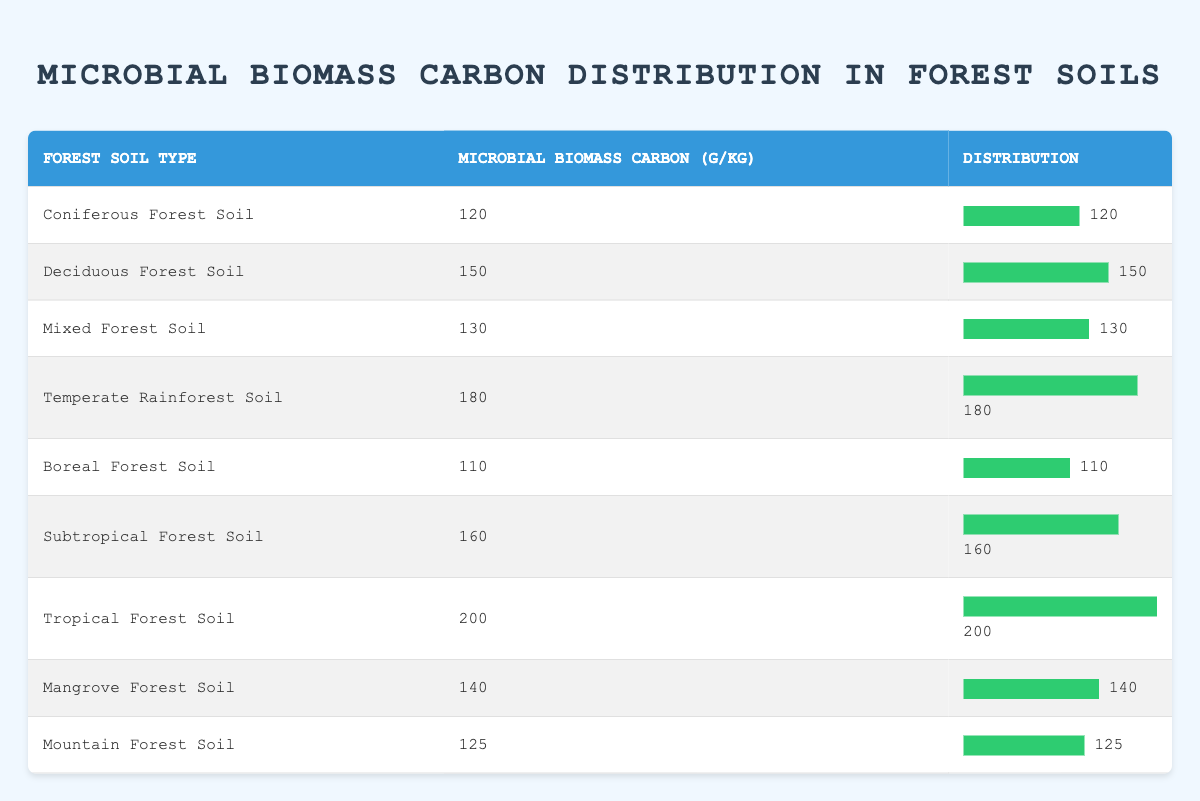What is the microbial biomass carbon value for Tropical Forest Soil? The table directly lists the microbial biomass carbon for each type of forest soil. For Tropical Forest Soil, the value is provided as 200 g/kg.
Answer: 200 g/kg Which forest soil type has the highest microbial biomass carbon? By inspecting the microbial biomass carbon values, the highest value in the table is for Tropical Forest Soil at 200 g/kg.
Answer: Tropical Forest Soil What is the combined microbial biomass carbon of Coniferous and Boreal Forest Soils? Coniferous Forest Soil has a value of 120 g/kg, and Boreal Forest Soil has 110 g/kg. Adding them together gives 120 + 110 = 230 g/kg.
Answer: 230 g/kg How many forest soil types have a microbial biomass carbon value greater than 150 g/kg? Analyzing the table, the soil types with values greater than 150 g/kg are: Deciduous (150 g/kg), Temperate Rainforest (180 g/kg), Subtropical (160 g/kg), Tropical (200 g/kg). This gives a total of 4 soil types with values above 150 g/kg.
Answer: 4 Is it true that Mangrove Forest Soil has less microbial biomass carbon than Deciduous Forest Soil? The table lists Mangrove Forest Soil at 140 g/kg and Deciduous Forest Soil at 150 g/kg. Since 140 is less than 150, the statement is true.
Answer: Yes What is the average microbial biomass carbon across all the forest soil types? To find the average, sum all the microbial biomass carbon values: 120 + 150 + 130 + 180 + 110 + 160 + 200 + 140 + 125 = 1,305. There are 9 soil types, so the average is 1,305 / 9 = 145 g/kg.
Answer: 145 g/kg Which soil type has the smallest microbial biomass carbon value, and what is that value? The smallest value in the table can be identified by reviewing the microbial biomass carbon figures. Boreal Forest Soil shows the smallest at 110 g/kg.
Answer: Boreal Forest Soil, 110 g/kg What is the difference in microbial biomass carbon between Tropical and Temperate Rainforest Soils? Tropical Forest Soil has 200 g/kg, and Temperate Rainforest Soil has 180 g/kg. The difference is calculated as 200 - 180 = 20 g/kg.
Answer: 20 g/kg 